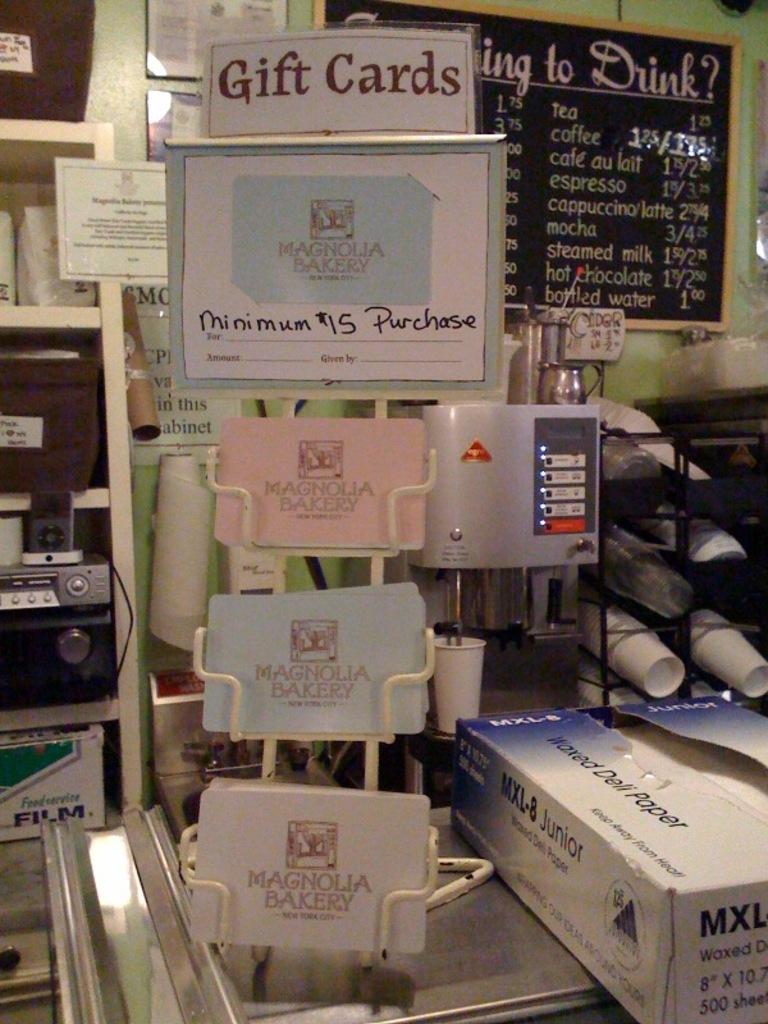<image>
Offer a succinct explanation of the picture presented. Gift cards shown in a shop with many items 